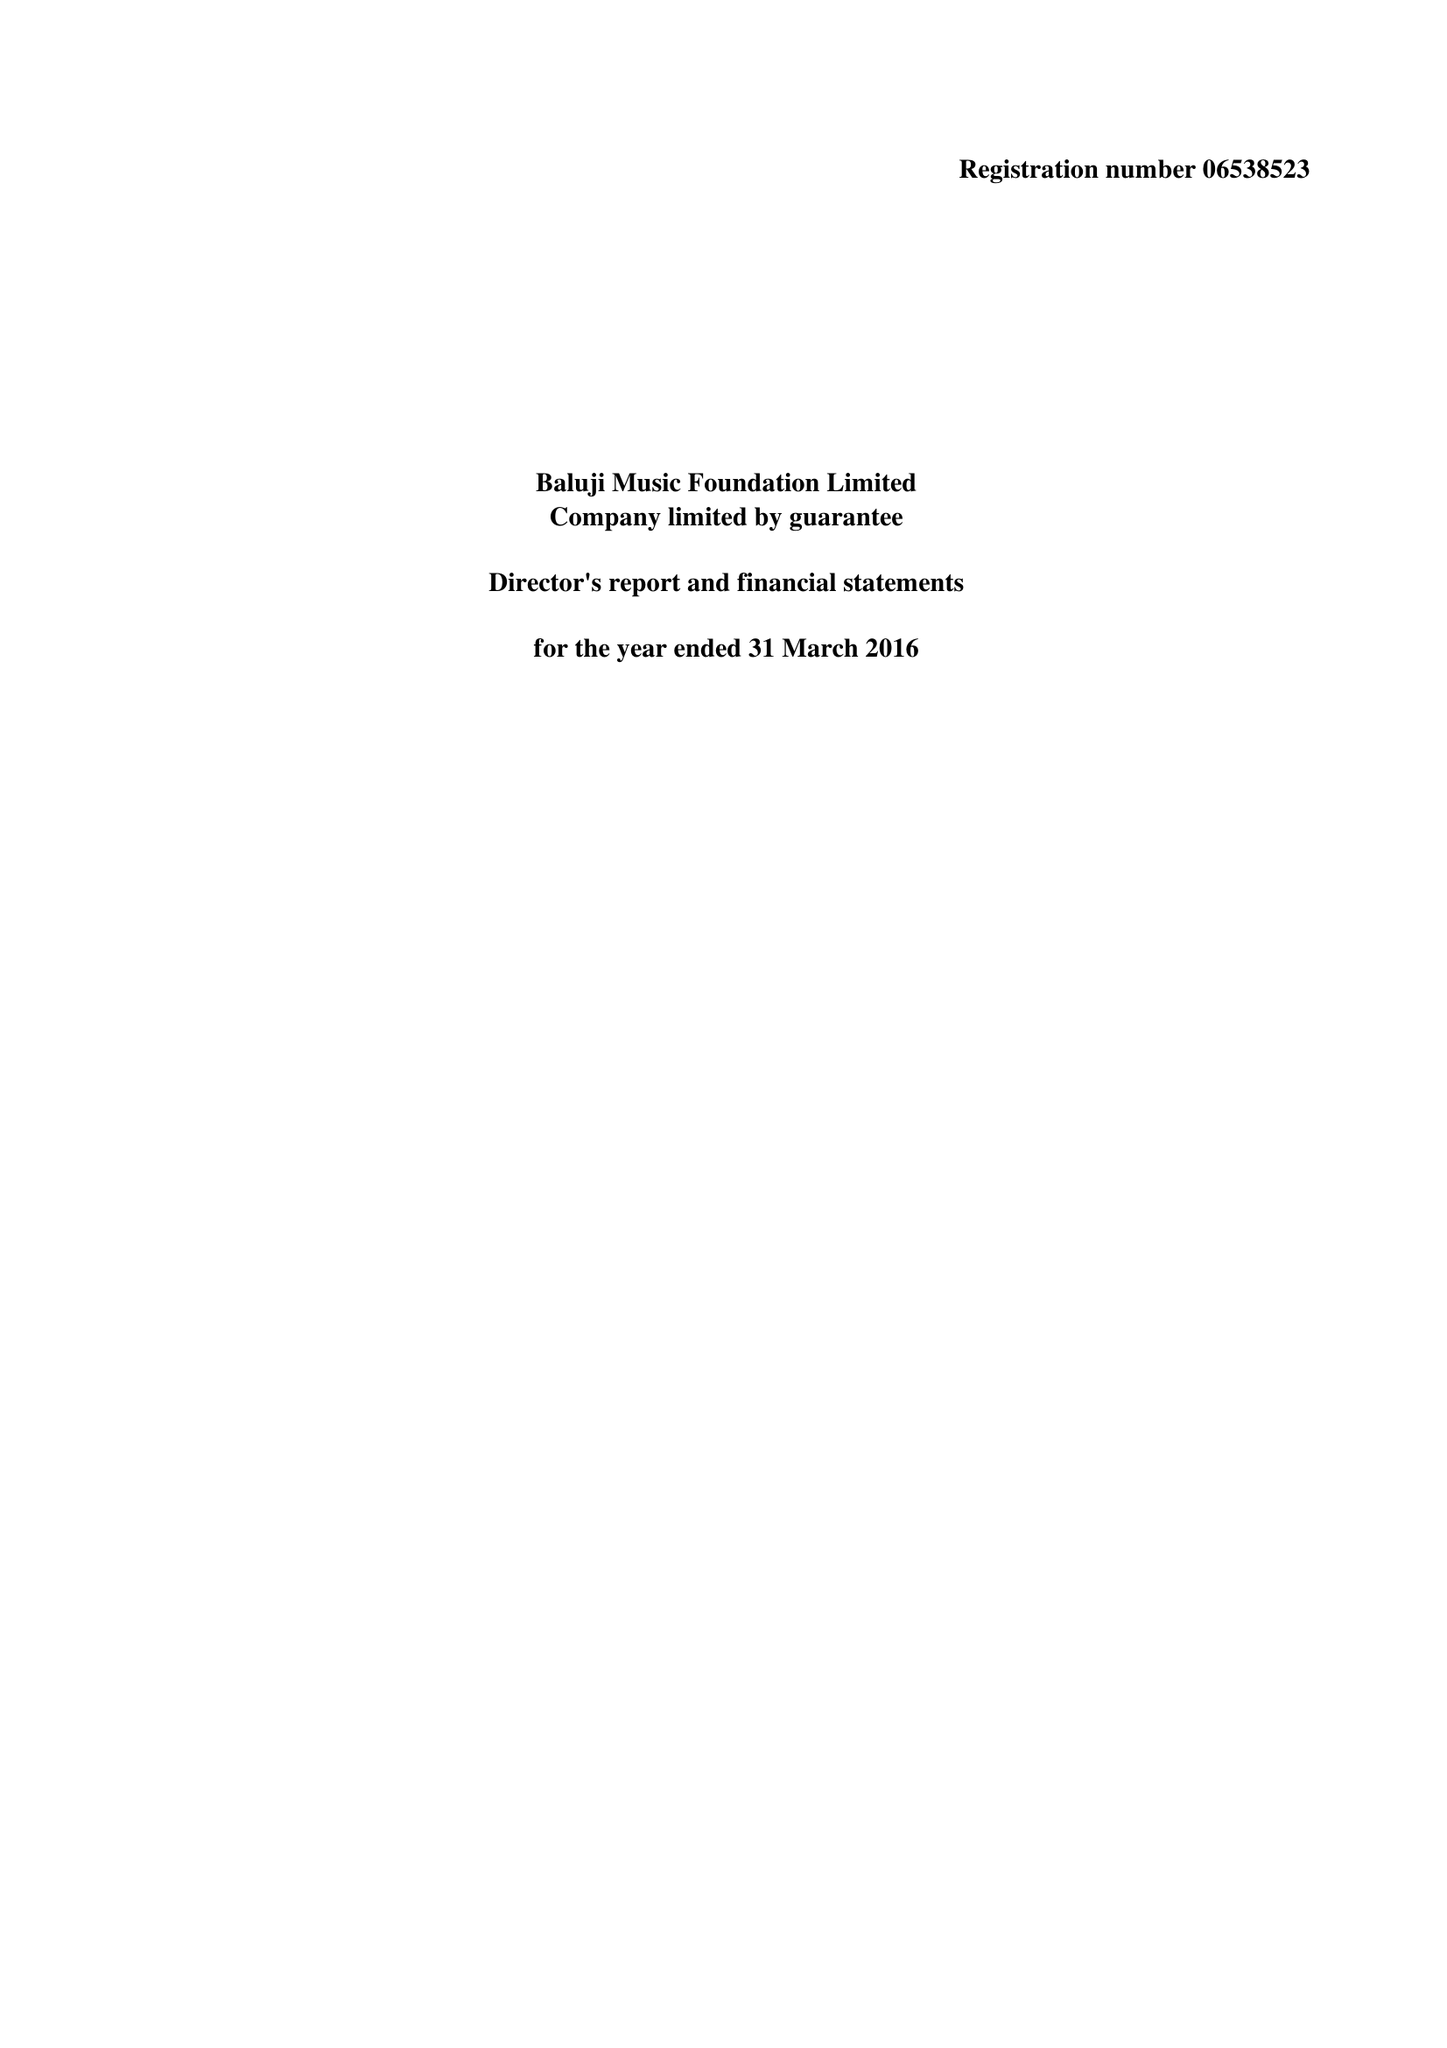What is the value for the address__postcode?
Answer the question using a single word or phrase. N5 2UU 